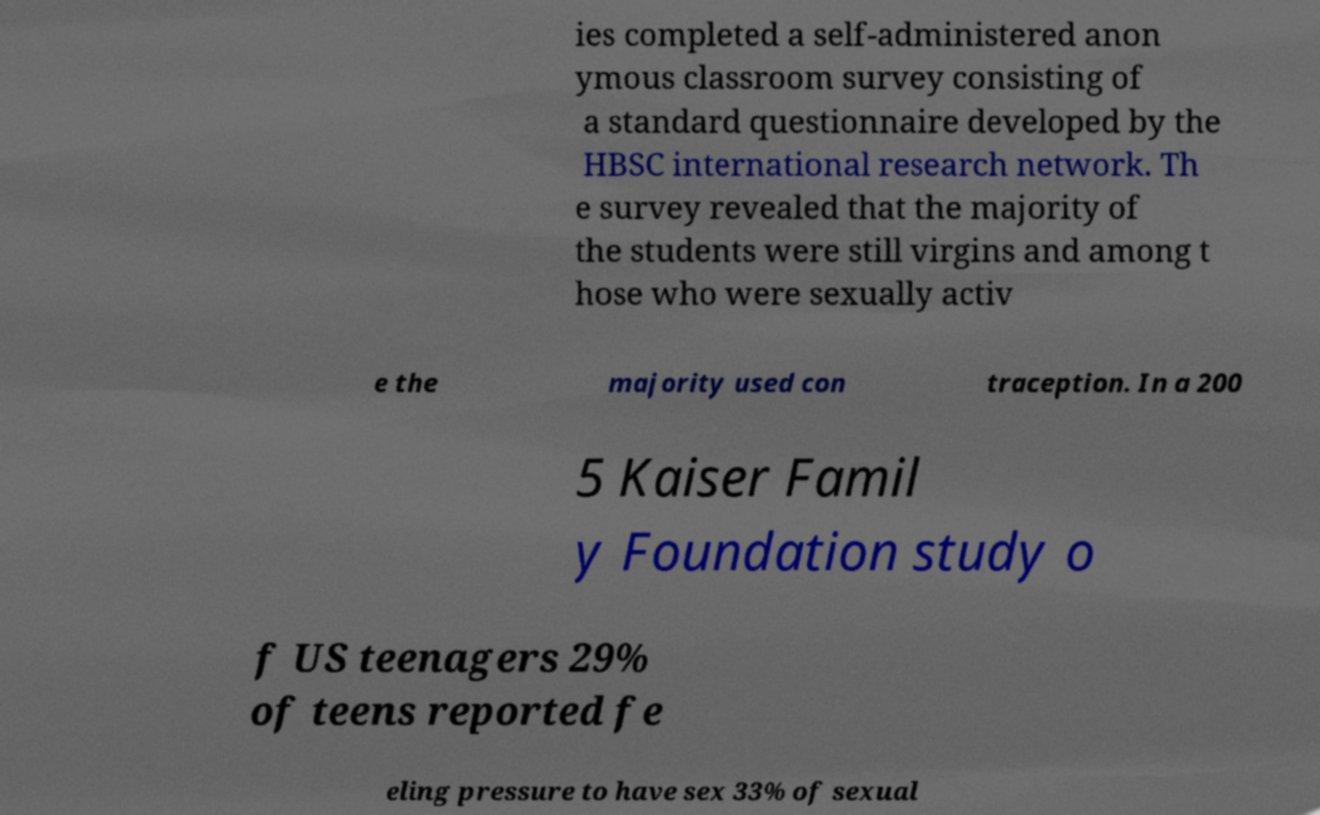What messages or text are displayed in this image? I need them in a readable, typed format. ies completed a self-administered anon ymous classroom survey consisting of a standard questionnaire developed by the HBSC international research network. Th e survey revealed that the majority of the students were still virgins and among t hose who were sexually activ e the majority used con traception. In a 200 5 Kaiser Famil y Foundation study o f US teenagers 29% of teens reported fe eling pressure to have sex 33% of sexual 